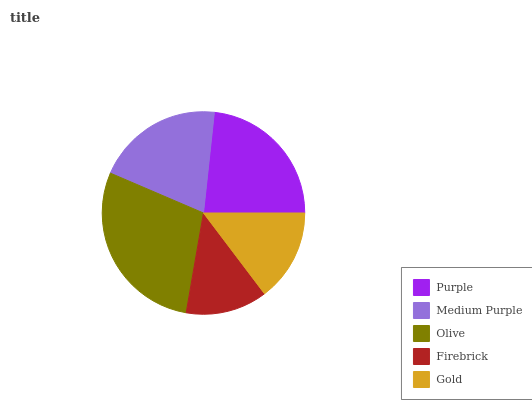Is Firebrick the minimum?
Answer yes or no. Yes. Is Olive the maximum?
Answer yes or no. Yes. Is Medium Purple the minimum?
Answer yes or no. No. Is Medium Purple the maximum?
Answer yes or no. No. Is Purple greater than Medium Purple?
Answer yes or no. Yes. Is Medium Purple less than Purple?
Answer yes or no. Yes. Is Medium Purple greater than Purple?
Answer yes or no. No. Is Purple less than Medium Purple?
Answer yes or no. No. Is Medium Purple the high median?
Answer yes or no. Yes. Is Medium Purple the low median?
Answer yes or no. Yes. Is Firebrick the high median?
Answer yes or no. No. Is Firebrick the low median?
Answer yes or no. No. 